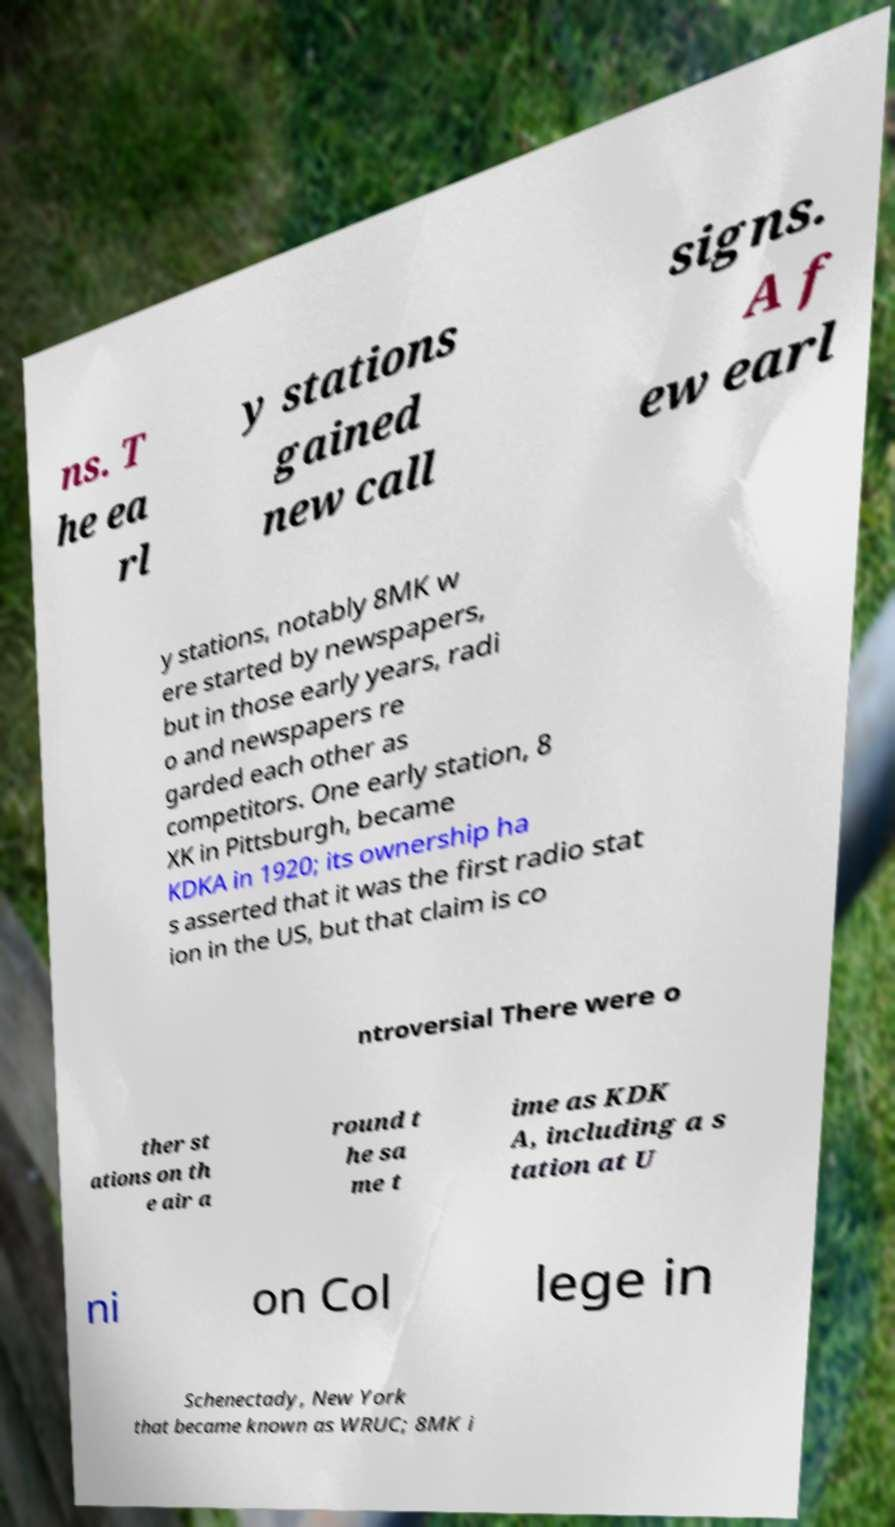Please read and relay the text visible in this image. What does it say? ns. T he ea rl y stations gained new call signs. A f ew earl y stations, notably 8MK w ere started by newspapers, but in those early years, radi o and newspapers re garded each other as competitors. One early station, 8 XK in Pittsburgh, became KDKA in 1920; its ownership ha s asserted that it was the first radio stat ion in the US, but that claim is co ntroversial There were o ther st ations on th e air a round t he sa me t ime as KDK A, including a s tation at U ni on Col lege in Schenectady, New York that became known as WRUC; 8MK i 